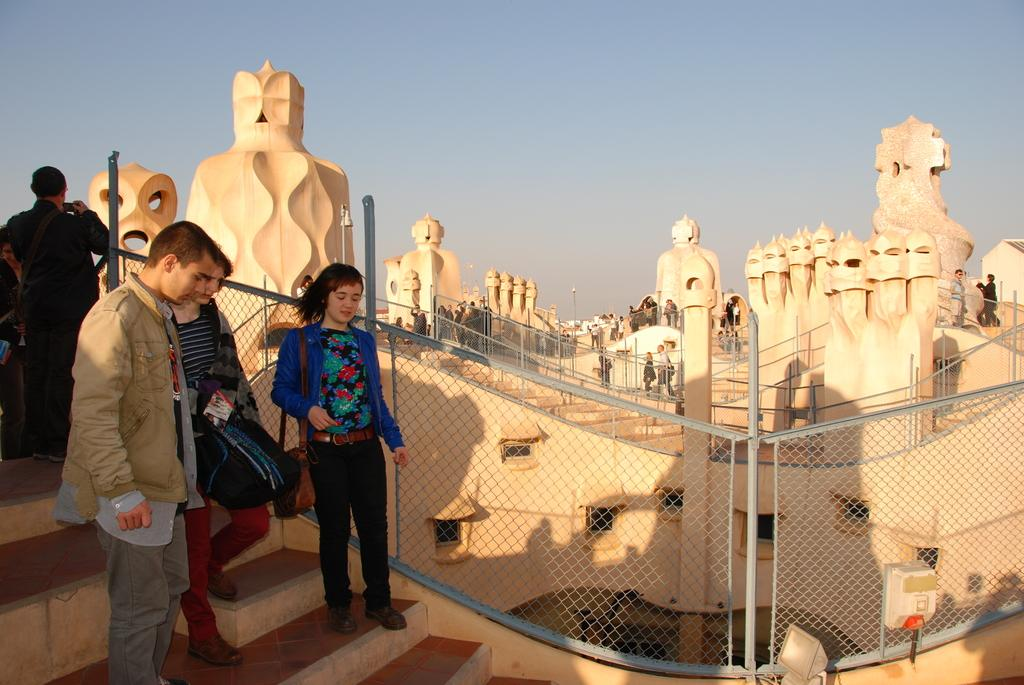How many people are in the image? There is a group of people in the image, but the exact number cannot be determined from the provided facts. What can be seen in the background of the image? There are buildings, a fence, metal rods, and lights visible in the background of the image. What type of cup is being used by the people in the image? There is no cup present in the image; the people are not holding or using any cups. 